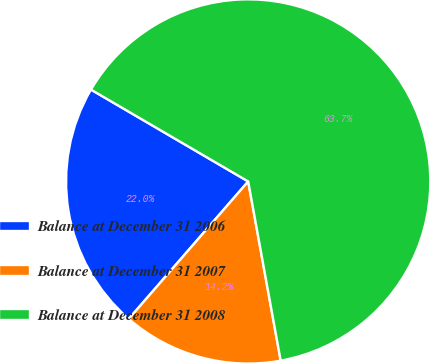Convert chart to OTSL. <chart><loc_0><loc_0><loc_500><loc_500><pie_chart><fcel>Balance at December 31 2006<fcel>Balance at December 31 2007<fcel>Balance at December 31 2008<nl><fcel>22.03%<fcel>14.24%<fcel>63.73%<nl></chart> 